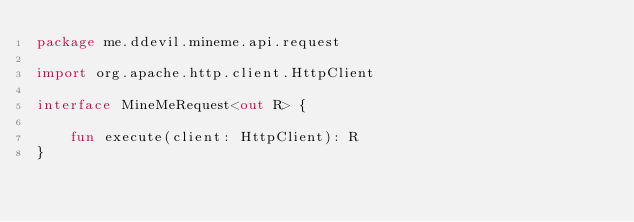<code> <loc_0><loc_0><loc_500><loc_500><_Kotlin_>package me.ddevil.mineme.api.request

import org.apache.http.client.HttpClient

interface MineMeRequest<out R> {

    fun execute(client: HttpClient): R
}

</code> 